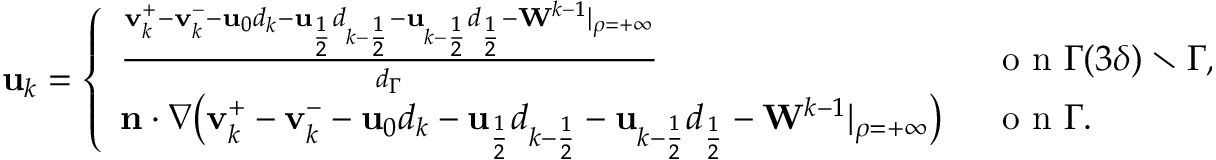Convert formula to latex. <formula><loc_0><loc_0><loc_500><loc_500>\begin{array} { r } { u _ { k } = \left \{ \begin{array} { l l } { \frac { v _ { k } ^ { + } - v _ { k } ^ { - } - u _ { 0 } d _ { k } - u _ { \frac { 1 } { 2 } } d _ { k - \frac { 1 } { 2 } } - u _ { k - \frac { 1 } { 2 } } d _ { \frac { 1 } { 2 } } - W ^ { k - 1 } | _ { \rho = + \infty } } { d _ { \Gamma } } } & { \ o n \Gamma ( 3 \delta ) \ \Gamma , } \\ { n \cdot \nabla \left ( v _ { k } ^ { + } - v _ { k } ^ { - } - u _ { 0 } d _ { k } - u _ { \frac { 1 } { 2 } } d _ { k - \frac { 1 } { 2 } } - u _ { k - \frac { 1 } { 2 } } d _ { \frac { 1 } { 2 } } - W ^ { k - 1 } | _ { \rho = + \infty } \right ) } & { \ o n \Gamma . } \end{array} } \end{array}</formula> 